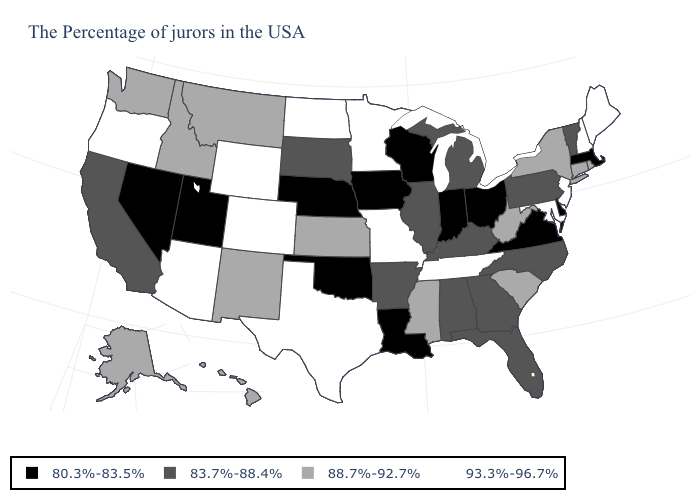Which states hav the highest value in the Northeast?
Keep it brief. Maine, New Hampshire, New Jersey. Is the legend a continuous bar?
Write a very short answer. No. Name the states that have a value in the range 83.7%-88.4%?
Be succinct. Vermont, Pennsylvania, North Carolina, Florida, Georgia, Michigan, Kentucky, Alabama, Illinois, Arkansas, South Dakota, California. Does Montana have a lower value than Rhode Island?
Quick response, please. No. What is the highest value in the USA?
Be succinct. 93.3%-96.7%. What is the value of North Dakota?
Be succinct. 93.3%-96.7%. Does Iowa have a higher value than Kentucky?
Write a very short answer. No. What is the lowest value in the South?
Keep it brief. 80.3%-83.5%. Does Virginia have a lower value than Maryland?
Short answer required. Yes. Does New Hampshire have the highest value in the USA?
Write a very short answer. Yes. Is the legend a continuous bar?
Give a very brief answer. No. What is the value of Mississippi?
Quick response, please. 88.7%-92.7%. What is the value of Kentucky?
Short answer required. 83.7%-88.4%. Does Arizona have a higher value than Oklahoma?
Write a very short answer. Yes. Name the states that have a value in the range 80.3%-83.5%?
Quick response, please. Massachusetts, Delaware, Virginia, Ohio, Indiana, Wisconsin, Louisiana, Iowa, Nebraska, Oklahoma, Utah, Nevada. 